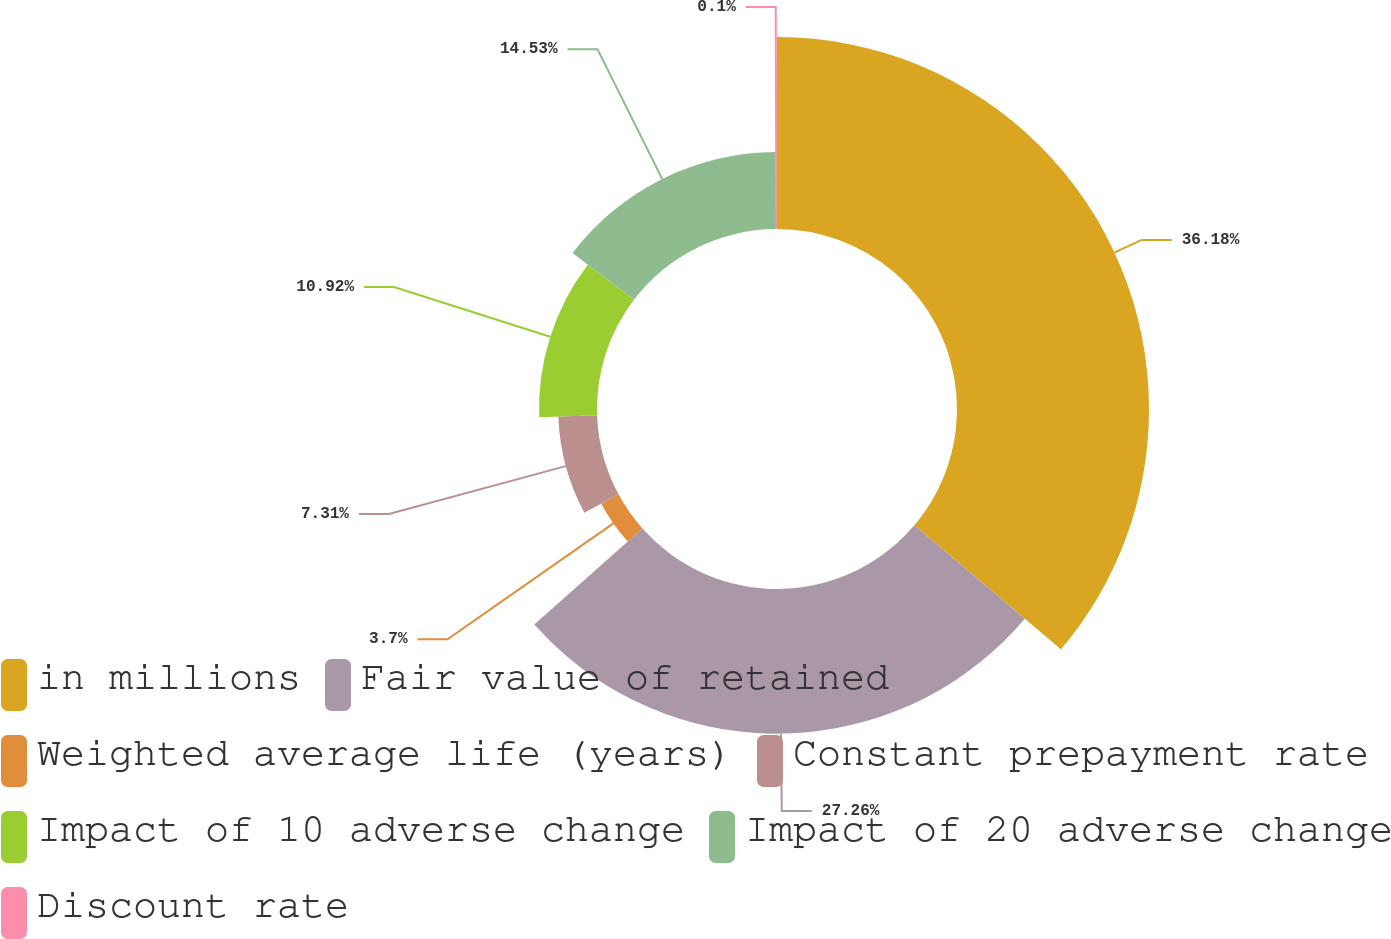Convert chart. <chart><loc_0><loc_0><loc_500><loc_500><pie_chart><fcel>in millions<fcel>Fair value of retained<fcel>Weighted average life (years)<fcel>Constant prepayment rate<fcel>Impact of 10 adverse change<fcel>Impact of 20 adverse change<fcel>Discount rate<nl><fcel>36.18%<fcel>27.26%<fcel>3.7%<fcel>7.31%<fcel>10.92%<fcel>14.53%<fcel>0.1%<nl></chart> 